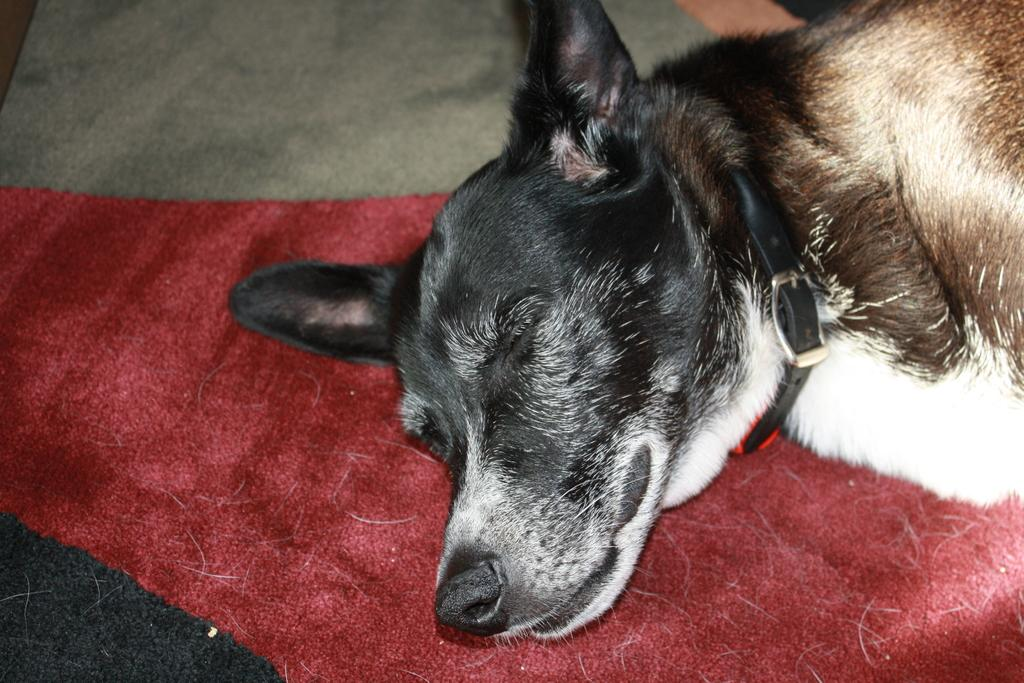What type of animal is in the image? There is a dog in the image. What is the dog doing in the image? The dog is sleeping on a mat. Can you describe the mat the dog is sleeping on? The mat is red, black, and gray in color. How would you describe the dog's coloring? The dog is black, brown, and white in color. What time does the clock show in the image? There is no clock present in the image. How many horses are visible in the image? There are no horses present in the image. 